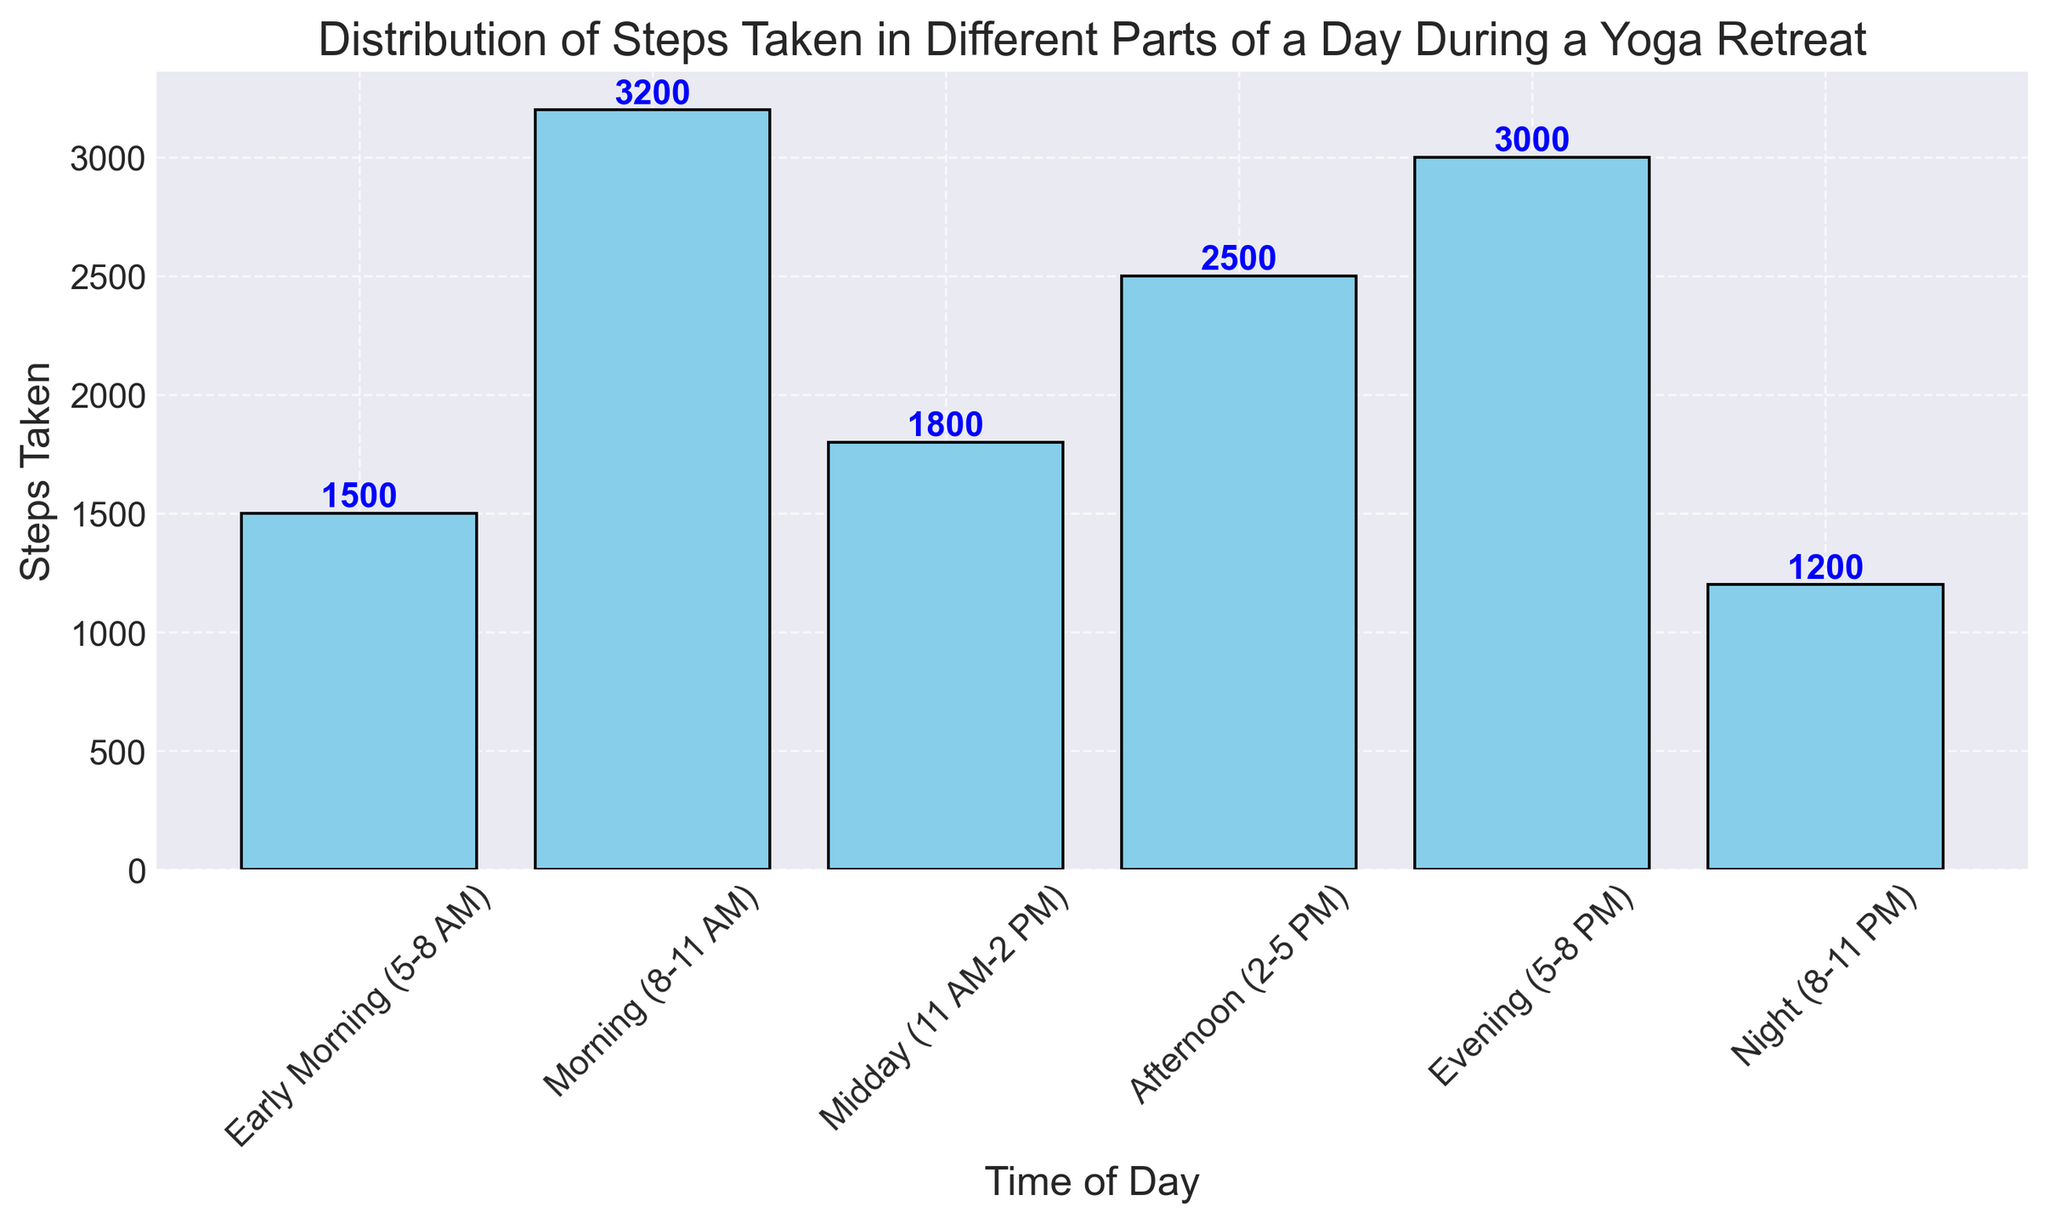What is the range of steps taken in the different parts of the day? The range is the difference between the maximum and minimum values of steps taken. The maximum steps taken are 3200 (Morning), and the minimum steps taken are 1200 (Night). Therefore, the range is 3200 - 1200 = 2000.
Answer: 2000 Which part of the day has the highest number of steps taken? By observing the heights of the bars, the Morning (8-11 AM) period has the highest bar, indicating the highest number of steps taken, which is 3200.
Answer: Morning (8-11 AM) How many more steps were taken in the Morning (8-11 AM) compared to the Early Morning (5-8 AM)? The number of steps taken in the Morning (8-11 AM) is 3200, and in the Early Morning (5-8 AM), it is 1500. The difference is 3200 - 1500 = 1700.
Answer: 1700 What time of day has the lowest number of steps taken? Looking at the lowest bar, Night (8-11 PM) has the lowest number of steps taken, which is 1200.
Answer: Night (8-11 PM) What is the average number of steps taken from Early Morning (5-8 AM) to Evening (5-8 PM)? Add the steps taken in each specified time of the day: 1500 + 3200 + 1800 + 2500 + 3000 = 12000. Divide this sum by the number of periods (5): 12000 / 5 = 2400.
Answer: 2400 How many steps are taken in total during the entire day? Sum up all the steps taken in each period of the day: 1500 + 3200 + 1800 + 2500 + 3000 + 1200 = 13200.
Answer: 13200 In which part of the day is there a noticeable drop in steps taken compared to the previous period? Comparing the bar heights, from Morning (3200) to Midday (1800), there is a noticeable drop in steps. The difference is 3200 - 1800 = 1400.
Answer: Midday (11 AM-2 PM) Which two periods together account for the highest number of steps? Add the steps of different pairs and find the highest sum. The pairs are:
- Early Morning + Morning: 1500 + 3200 = 4700
- Morning + Midday: 3200 + 1800 = 5000
- Midday + Afternoon: 1800 + 2500 = 4300
- Afternoon + Evening: 2500 + 3000 = 5500 (highest)
- Evening + Night: 3000 + 1200 = 4200
So, the highest combined steps are in the Afternoon and Evening.
Answer: Afternoon and Evening By what percentage are the steps taken in the Early Morning (5-8 AM) less than the Morning (8-11 AM)? Calculate the difference in steps taken between the two periods: 3200 - 1500 = 1700. Then, calculate the percentage difference: (1700 / 3200) * 100 ≈ 53.12%.
Answer: 53.12% What is the median number of steps taken in different parts of the day? Ordered list of steps: 1200, 1500, 1800, 2500, 3000, 3200. The median value is the average of the middle two numbers in this sorted list: (1800 + 2500) / 2 = 2150.
Answer: 2150 